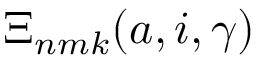<formula> <loc_0><loc_0><loc_500><loc_500>\Xi _ { n m k } ( a , i , \gamma )</formula> 